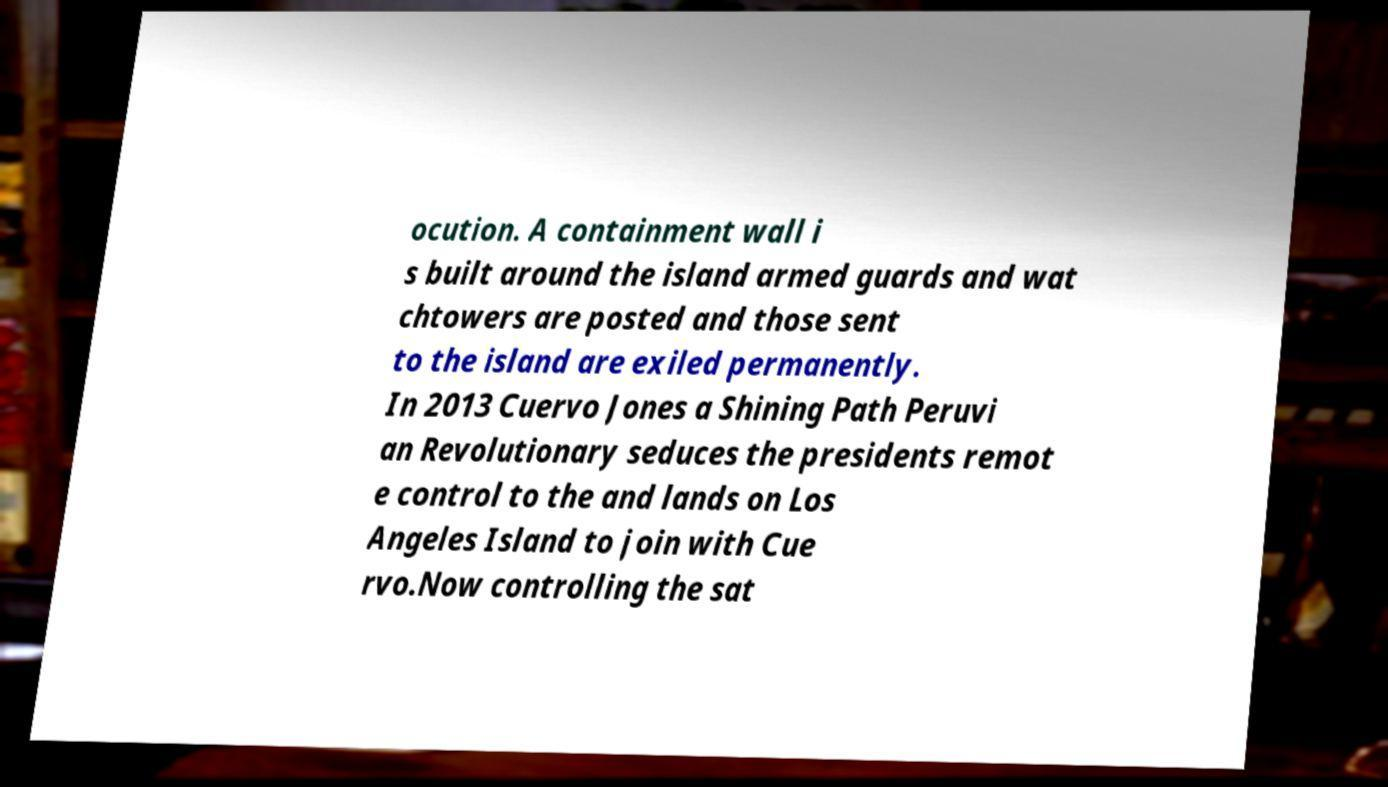There's text embedded in this image that I need extracted. Can you transcribe it verbatim? ocution. A containment wall i s built around the island armed guards and wat chtowers are posted and those sent to the island are exiled permanently. In 2013 Cuervo Jones a Shining Path Peruvi an Revolutionary seduces the presidents remot e control to the and lands on Los Angeles Island to join with Cue rvo.Now controlling the sat 